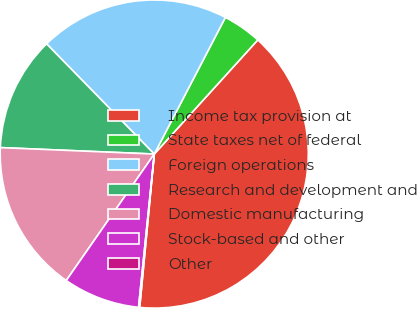Convert chart. <chart><loc_0><loc_0><loc_500><loc_500><pie_chart><fcel>Income tax provision at<fcel>State taxes net of federal<fcel>Foreign operations<fcel>Research and development and<fcel>Domestic manufacturing<fcel>Stock-based and other<fcel>Other<nl><fcel>39.78%<fcel>4.09%<fcel>19.95%<fcel>12.02%<fcel>15.99%<fcel>8.05%<fcel>0.12%<nl></chart> 